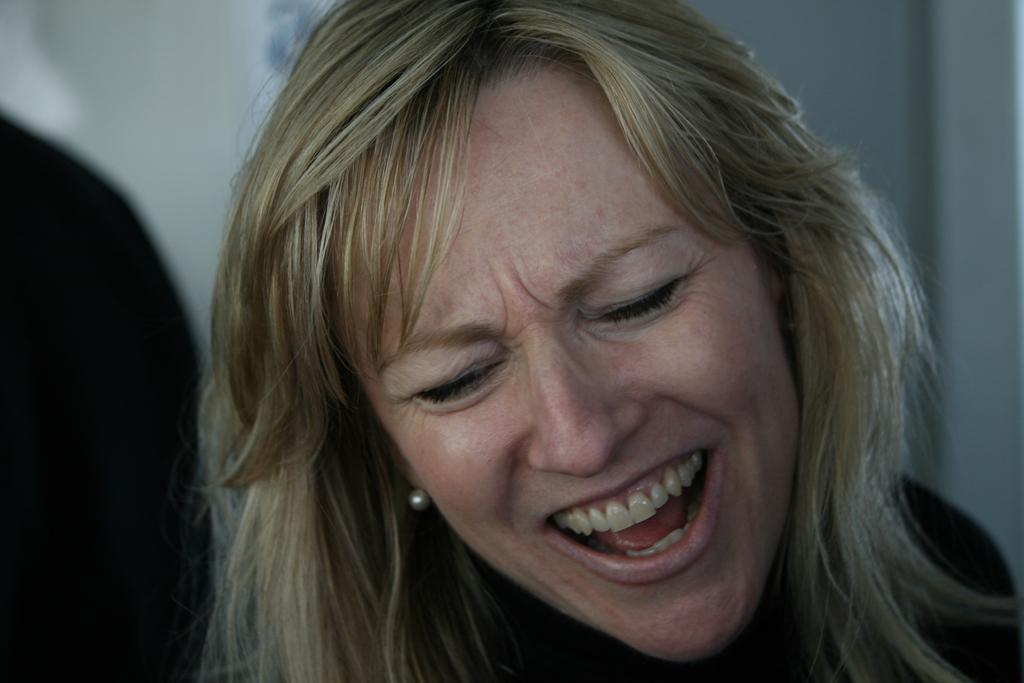Can you describe this image briefly? In this image I can see a woman and I can also see smile on her face. On the left side I can see a black colour thing and I can also see this image is little bit blurry in the background. 